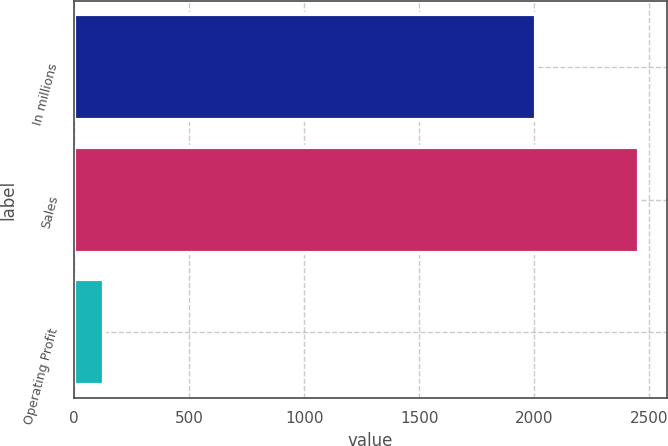<chart> <loc_0><loc_0><loc_500><loc_500><bar_chart><fcel>In millions<fcel>Sales<fcel>Operating Profit<nl><fcel>2006<fcel>2455<fcel>131<nl></chart> 